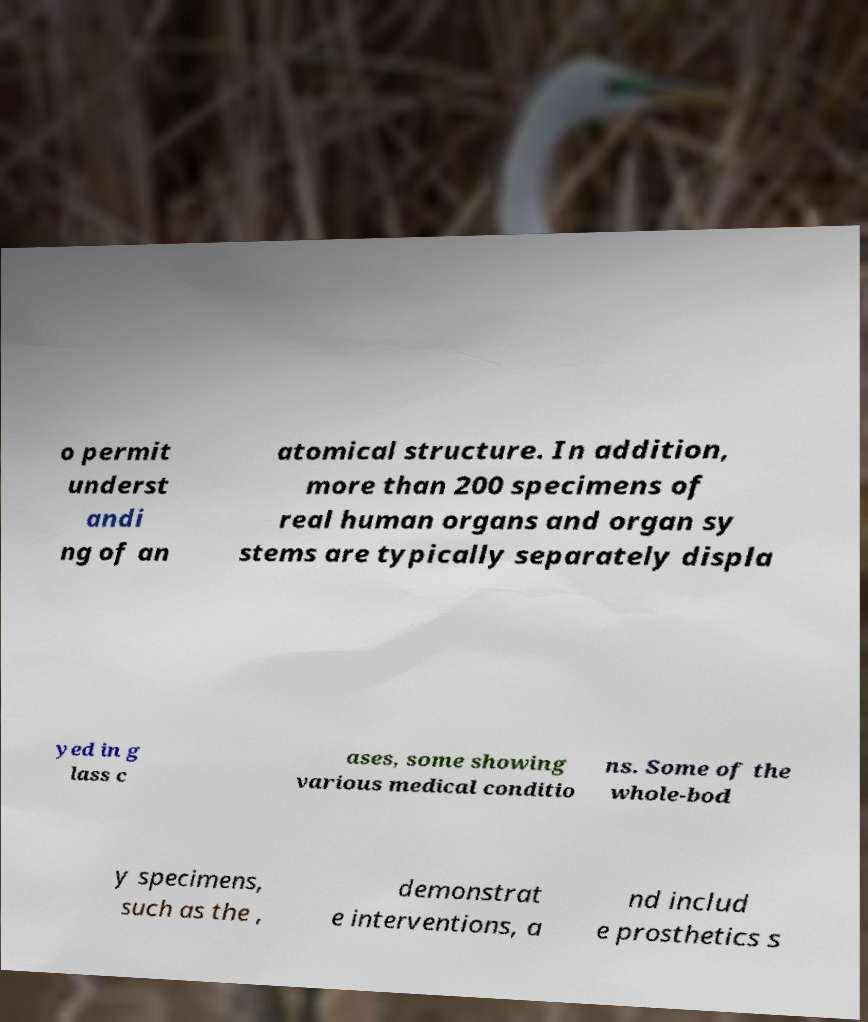Please identify and transcribe the text found in this image. o permit underst andi ng of an atomical structure. In addition, more than 200 specimens of real human organs and organ sy stems are typically separately displa yed in g lass c ases, some showing various medical conditio ns. Some of the whole-bod y specimens, such as the , demonstrat e interventions, a nd includ e prosthetics s 